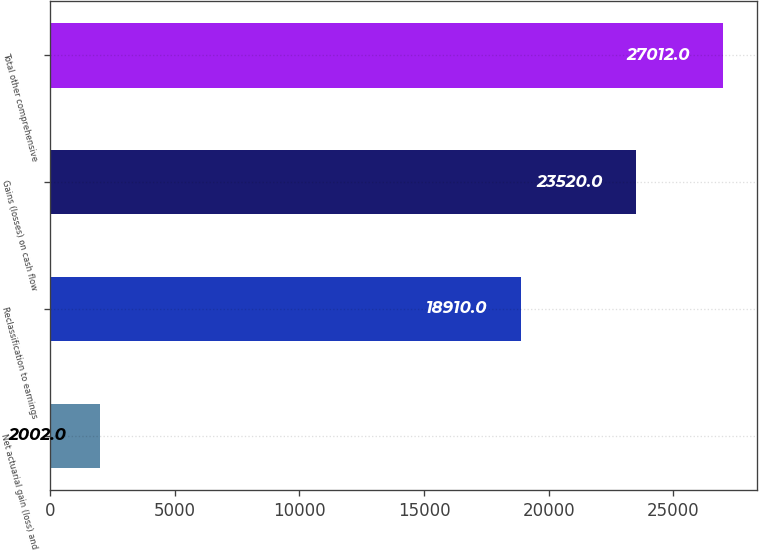<chart> <loc_0><loc_0><loc_500><loc_500><bar_chart><fcel>Net actuarial gain (loss) and<fcel>Reclassification to earnings<fcel>Gains (losses) on cash flow<fcel>Total other comprehensive<nl><fcel>2002<fcel>18910<fcel>23520<fcel>27012<nl></chart> 